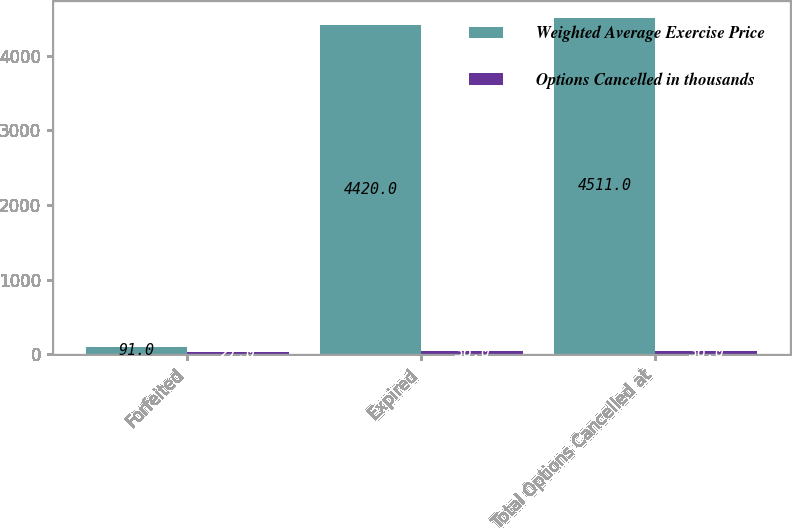<chart> <loc_0><loc_0><loc_500><loc_500><stacked_bar_chart><ecel><fcel>Forfeited<fcel>Expired<fcel>Total Options Cancelled at<nl><fcel>Weighted Average Exercise Price<fcel>91<fcel>4420<fcel>4511<nl><fcel>Options Cancelled in thousands<fcel>27<fcel>36<fcel>36<nl></chart> 